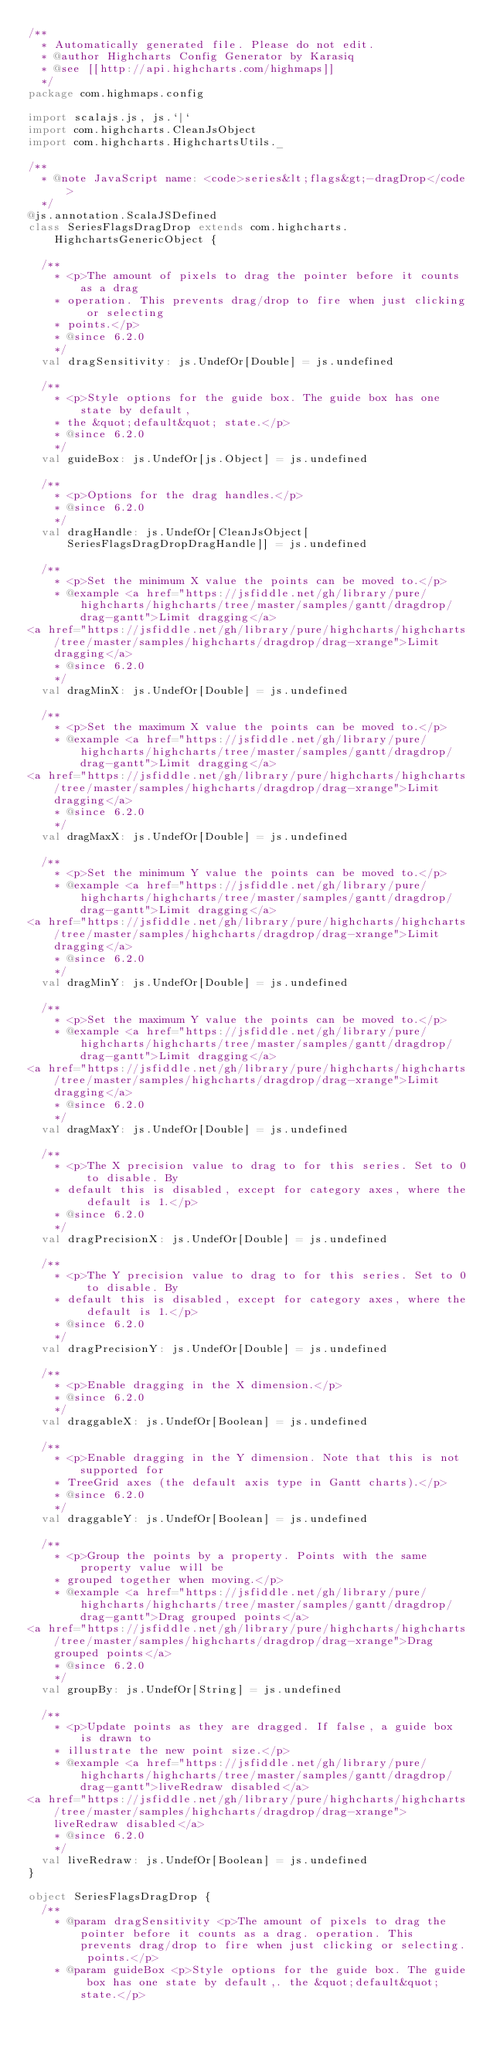<code> <loc_0><loc_0><loc_500><loc_500><_Scala_>/**
  * Automatically generated file. Please do not edit.
  * @author Highcharts Config Generator by Karasiq
  * @see [[http://api.highcharts.com/highmaps]]
  */
package com.highmaps.config

import scalajs.js, js.`|`
import com.highcharts.CleanJsObject
import com.highcharts.HighchartsUtils._

/**
  * @note JavaScript name: <code>series&lt;flags&gt;-dragDrop</code>
  */
@js.annotation.ScalaJSDefined
class SeriesFlagsDragDrop extends com.highcharts.HighchartsGenericObject {

  /**
    * <p>The amount of pixels to drag the pointer before it counts as a drag
    * operation. This prevents drag/drop to fire when just clicking or selecting
    * points.</p>
    * @since 6.2.0
    */
  val dragSensitivity: js.UndefOr[Double] = js.undefined

  /**
    * <p>Style options for the guide box. The guide box has one state by default,
    * the &quot;default&quot; state.</p>
    * @since 6.2.0
    */
  val guideBox: js.UndefOr[js.Object] = js.undefined

  /**
    * <p>Options for the drag handles.</p>
    * @since 6.2.0
    */
  val dragHandle: js.UndefOr[CleanJsObject[SeriesFlagsDragDropDragHandle]] = js.undefined

  /**
    * <p>Set the minimum X value the points can be moved to.</p>
    * @example <a href="https://jsfiddle.net/gh/library/pure/highcharts/highcharts/tree/master/samples/gantt/dragdrop/drag-gantt">Limit dragging</a>
<a href="https://jsfiddle.net/gh/library/pure/highcharts/highcharts/tree/master/samples/highcharts/dragdrop/drag-xrange">Limit dragging</a>
    * @since 6.2.0
    */
  val dragMinX: js.UndefOr[Double] = js.undefined

  /**
    * <p>Set the maximum X value the points can be moved to.</p>
    * @example <a href="https://jsfiddle.net/gh/library/pure/highcharts/highcharts/tree/master/samples/gantt/dragdrop/drag-gantt">Limit dragging</a>
<a href="https://jsfiddle.net/gh/library/pure/highcharts/highcharts/tree/master/samples/highcharts/dragdrop/drag-xrange">Limit dragging</a>
    * @since 6.2.0
    */
  val dragMaxX: js.UndefOr[Double] = js.undefined

  /**
    * <p>Set the minimum Y value the points can be moved to.</p>
    * @example <a href="https://jsfiddle.net/gh/library/pure/highcharts/highcharts/tree/master/samples/gantt/dragdrop/drag-gantt">Limit dragging</a>
<a href="https://jsfiddle.net/gh/library/pure/highcharts/highcharts/tree/master/samples/highcharts/dragdrop/drag-xrange">Limit dragging</a>
    * @since 6.2.0
    */
  val dragMinY: js.UndefOr[Double] = js.undefined

  /**
    * <p>Set the maximum Y value the points can be moved to.</p>
    * @example <a href="https://jsfiddle.net/gh/library/pure/highcharts/highcharts/tree/master/samples/gantt/dragdrop/drag-gantt">Limit dragging</a>
<a href="https://jsfiddle.net/gh/library/pure/highcharts/highcharts/tree/master/samples/highcharts/dragdrop/drag-xrange">Limit dragging</a>
    * @since 6.2.0
    */
  val dragMaxY: js.UndefOr[Double] = js.undefined

  /**
    * <p>The X precision value to drag to for this series. Set to 0 to disable. By
    * default this is disabled, except for category axes, where the default is 1.</p>
    * @since 6.2.0
    */
  val dragPrecisionX: js.UndefOr[Double] = js.undefined

  /**
    * <p>The Y precision value to drag to for this series. Set to 0 to disable. By
    * default this is disabled, except for category axes, where the default is 1.</p>
    * @since 6.2.0
    */
  val dragPrecisionY: js.UndefOr[Double] = js.undefined

  /**
    * <p>Enable dragging in the X dimension.</p>
    * @since 6.2.0
    */
  val draggableX: js.UndefOr[Boolean] = js.undefined

  /**
    * <p>Enable dragging in the Y dimension. Note that this is not supported for
    * TreeGrid axes (the default axis type in Gantt charts).</p>
    * @since 6.2.0
    */
  val draggableY: js.UndefOr[Boolean] = js.undefined

  /**
    * <p>Group the points by a property. Points with the same property value will be
    * grouped together when moving.</p>
    * @example <a href="https://jsfiddle.net/gh/library/pure/highcharts/highcharts/tree/master/samples/gantt/dragdrop/drag-gantt">Drag grouped points</a>
<a href="https://jsfiddle.net/gh/library/pure/highcharts/highcharts/tree/master/samples/highcharts/dragdrop/drag-xrange">Drag grouped points</a>
    * @since 6.2.0
    */
  val groupBy: js.UndefOr[String] = js.undefined

  /**
    * <p>Update points as they are dragged. If false, a guide box is drawn to
    * illustrate the new point size.</p>
    * @example <a href="https://jsfiddle.net/gh/library/pure/highcharts/highcharts/tree/master/samples/gantt/dragdrop/drag-gantt">liveRedraw disabled</a>
<a href="https://jsfiddle.net/gh/library/pure/highcharts/highcharts/tree/master/samples/highcharts/dragdrop/drag-xrange">liveRedraw disabled</a>
    * @since 6.2.0
    */
  val liveRedraw: js.UndefOr[Boolean] = js.undefined
}

object SeriesFlagsDragDrop {
  /**
    * @param dragSensitivity <p>The amount of pixels to drag the pointer before it counts as a drag. operation. This prevents drag/drop to fire when just clicking or selecting. points.</p>
    * @param guideBox <p>Style options for the guide box. The guide box has one state by default,. the &quot;default&quot; state.</p></code> 